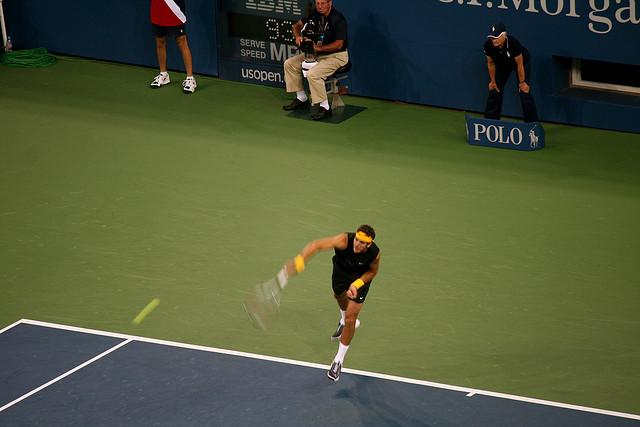What clothing brand logo is seen here?
Concise answer only. Polo. Where is the player?
Quick response, please. Tennis court. Who is one of the sponsors of the match?
Keep it brief. Polo. How many men are in pants?
Short answer required. 2. What is the man pictured getting ready to do?
Be succinct. Hit ball. How many people are in the picture?
Keep it brief. 4. What is the headband protecting the man from?
Concise answer only. Sweat. Did he hit the ball?
Concise answer only. Yes. 